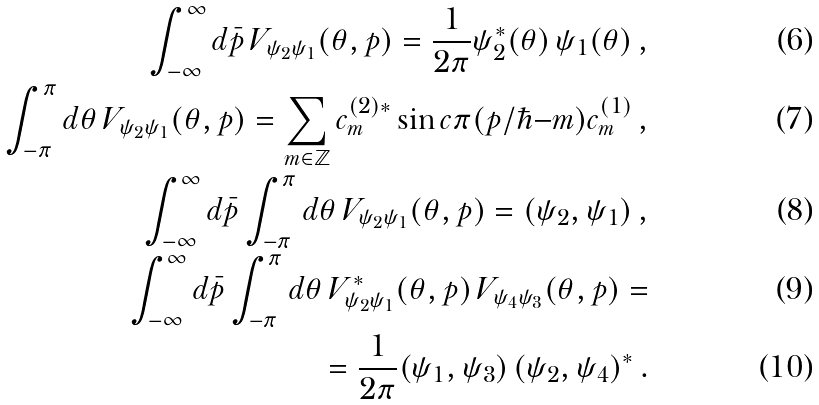Convert formula to latex. <formula><loc_0><loc_0><loc_500><loc_500>\int _ { - \infty } ^ { \infty } d \bar { p } \, V _ { \psi _ { 2 } \psi _ { 1 } } ( \theta , p ) = \frac { 1 } { 2 \pi } \psi _ { 2 } ^ { \ast } ( \theta ) \, \psi _ { 1 } ( \theta ) \, , \\ \int _ { - \pi } ^ { \pi } d \theta \, V _ { \psi _ { 2 } \psi _ { 1 } } ( \theta , p ) = \sum _ { m \in \mathbb { Z } } c _ { m } ^ { ( 2 ) \ast } \sin c \pi ( p / \hbar { - } m ) c _ { m } ^ { ( 1 ) } \, , \\ \int _ { - \infty } ^ { \infty } d \bar { p } \int _ { - \pi } ^ { \pi } d \theta \, V _ { \psi _ { 2 } \psi _ { 1 } } ( \theta , p ) = ( \psi _ { 2 } , \psi _ { 1 } ) \, , \\ \int _ { - \infty } ^ { \infty } d \bar { p } \int _ { - \pi } ^ { \pi } d \theta \, V ^ { \ast } _ { \psi _ { 2 } \psi _ { 1 } } ( \theta , p ) \, V _ { \psi _ { 4 } \psi _ { 3 } } ( \theta , p ) = \\ = \frac { 1 } { 2 \pi } ( \psi _ { 1 } , \psi _ { 3 } ) \, ( \psi _ { 2 } , \psi _ { 4 } ) ^ { \ast } \, .</formula> 